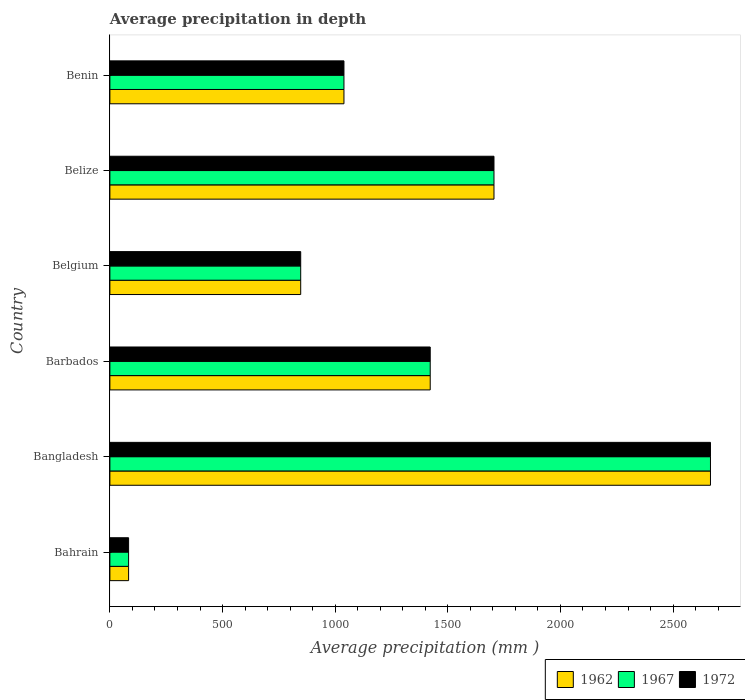How many bars are there on the 6th tick from the bottom?
Give a very brief answer. 3. What is the label of the 1st group of bars from the top?
Give a very brief answer. Benin. What is the average precipitation in 1967 in Belize?
Provide a short and direct response. 1705. Across all countries, what is the maximum average precipitation in 1967?
Offer a very short reply. 2666. Across all countries, what is the minimum average precipitation in 1967?
Your answer should be compact. 83. In which country was the average precipitation in 1962 maximum?
Your answer should be very brief. Bangladesh. In which country was the average precipitation in 1962 minimum?
Your answer should be compact. Bahrain. What is the total average precipitation in 1967 in the graph?
Make the answer very short. 7762. What is the difference between the average precipitation in 1962 in Belize and that in Benin?
Provide a short and direct response. 666. What is the difference between the average precipitation in 1967 in Bangladesh and the average precipitation in 1972 in Bahrain?
Your response must be concise. 2583. What is the average average precipitation in 1972 per country?
Provide a succinct answer. 1293.67. In how many countries, is the average precipitation in 1962 greater than 1300 mm?
Ensure brevity in your answer.  3. What is the ratio of the average precipitation in 1972 in Bahrain to that in Barbados?
Give a very brief answer. 0.06. What is the difference between the highest and the second highest average precipitation in 1967?
Offer a very short reply. 961. What is the difference between the highest and the lowest average precipitation in 1967?
Give a very brief answer. 2583. In how many countries, is the average precipitation in 1962 greater than the average average precipitation in 1962 taken over all countries?
Your answer should be very brief. 3. Is the sum of the average precipitation in 1967 in Barbados and Belize greater than the maximum average precipitation in 1962 across all countries?
Provide a short and direct response. Yes. What does the 1st bar from the top in Bahrain represents?
Provide a short and direct response. 1972. How many bars are there?
Offer a very short reply. 18. How many countries are there in the graph?
Keep it short and to the point. 6. Does the graph contain any zero values?
Ensure brevity in your answer.  No. Does the graph contain grids?
Make the answer very short. No. Where does the legend appear in the graph?
Your answer should be compact. Bottom right. How many legend labels are there?
Provide a short and direct response. 3. What is the title of the graph?
Keep it short and to the point. Average precipitation in depth. Does "1981" appear as one of the legend labels in the graph?
Ensure brevity in your answer.  No. What is the label or title of the X-axis?
Your answer should be very brief. Average precipitation (mm ). What is the label or title of the Y-axis?
Offer a terse response. Country. What is the Average precipitation (mm ) in 1972 in Bahrain?
Your response must be concise. 83. What is the Average precipitation (mm ) in 1962 in Bangladesh?
Offer a very short reply. 2666. What is the Average precipitation (mm ) of 1967 in Bangladesh?
Your response must be concise. 2666. What is the Average precipitation (mm ) of 1972 in Bangladesh?
Your answer should be very brief. 2666. What is the Average precipitation (mm ) in 1962 in Barbados?
Ensure brevity in your answer.  1422. What is the Average precipitation (mm ) of 1967 in Barbados?
Your answer should be very brief. 1422. What is the Average precipitation (mm ) in 1972 in Barbados?
Ensure brevity in your answer.  1422. What is the Average precipitation (mm ) in 1962 in Belgium?
Make the answer very short. 847. What is the Average precipitation (mm ) in 1967 in Belgium?
Offer a terse response. 847. What is the Average precipitation (mm ) in 1972 in Belgium?
Give a very brief answer. 847. What is the Average precipitation (mm ) in 1962 in Belize?
Offer a terse response. 1705. What is the Average precipitation (mm ) in 1967 in Belize?
Your answer should be very brief. 1705. What is the Average precipitation (mm ) in 1972 in Belize?
Offer a very short reply. 1705. What is the Average precipitation (mm ) of 1962 in Benin?
Your answer should be compact. 1039. What is the Average precipitation (mm ) of 1967 in Benin?
Make the answer very short. 1039. What is the Average precipitation (mm ) in 1972 in Benin?
Offer a very short reply. 1039. Across all countries, what is the maximum Average precipitation (mm ) of 1962?
Keep it short and to the point. 2666. Across all countries, what is the maximum Average precipitation (mm ) in 1967?
Provide a succinct answer. 2666. Across all countries, what is the maximum Average precipitation (mm ) in 1972?
Keep it short and to the point. 2666. Across all countries, what is the minimum Average precipitation (mm ) in 1967?
Ensure brevity in your answer.  83. Across all countries, what is the minimum Average precipitation (mm ) in 1972?
Give a very brief answer. 83. What is the total Average precipitation (mm ) in 1962 in the graph?
Provide a short and direct response. 7762. What is the total Average precipitation (mm ) of 1967 in the graph?
Give a very brief answer. 7762. What is the total Average precipitation (mm ) in 1972 in the graph?
Give a very brief answer. 7762. What is the difference between the Average precipitation (mm ) of 1962 in Bahrain and that in Bangladesh?
Your answer should be compact. -2583. What is the difference between the Average precipitation (mm ) in 1967 in Bahrain and that in Bangladesh?
Keep it short and to the point. -2583. What is the difference between the Average precipitation (mm ) in 1972 in Bahrain and that in Bangladesh?
Ensure brevity in your answer.  -2583. What is the difference between the Average precipitation (mm ) of 1962 in Bahrain and that in Barbados?
Offer a very short reply. -1339. What is the difference between the Average precipitation (mm ) of 1967 in Bahrain and that in Barbados?
Make the answer very short. -1339. What is the difference between the Average precipitation (mm ) of 1972 in Bahrain and that in Barbados?
Make the answer very short. -1339. What is the difference between the Average precipitation (mm ) of 1962 in Bahrain and that in Belgium?
Give a very brief answer. -764. What is the difference between the Average precipitation (mm ) of 1967 in Bahrain and that in Belgium?
Offer a very short reply. -764. What is the difference between the Average precipitation (mm ) in 1972 in Bahrain and that in Belgium?
Your response must be concise. -764. What is the difference between the Average precipitation (mm ) in 1962 in Bahrain and that in Belize?
Provide a short and direct response. -1622. What is the difference between the Average precipitation (mm ) in 1967 in Bahrain and that in Belize?
Provide a short and direct response. -1622. What is the difference between the Average precipitation (mm ) of 1972 in Bahrain and that in Belize?
Provide a succinct answer. -1622. What is the difference between the Average precipitation (mm ) of 1962 in Bahrain and that in Benin?
Give a very brief answer. -956. What is the difference between the Average precipitation (mm ) in 1967 in Bahrain and that in Benin?
Give a very brief answer. -956. What is the difference between the Average precipitation (mm ) in 1972 in Bahrain and that in Benin?
Provide a short and direct response. -956. What is the difference between the Average precipitation (mm ) of 1962 in Bangladesh and that in Barbados?
Give a very brief answer. 1244. What is the difference between the Average precipitation (mm ) in 1967 in Bangladesh and that in Barbados?
Offer a very short reply. 1244. What is the difference between the Average precipitation (mm ) in 1972 in Bangladesh and that in Barbados?
Your answer should be very brief. 1244. What is the difference between the Average precipitation (mm ) in 1962 in Bangladesh and that in Belgium?
Ensure brevity in your answer.  1819. What is the difference between the Average precipitation (mm ) of 1967 in Bangladesh and that in Belgium?
Your response must be concise. 1819. What is the difference between the Average precipitation (mm ) in 1972 in Bangladesh and that in Belgium?
Offer a terse response. 1819. What is the difference between the Average precipitation (mm ) in 1962 in Bangladesh and that in Belize?
Provide a short and direct response. 961. What is the difference between the Average precipitation (mm ) of 1967 in Bangladesh and that in Belize?
Your response must be concise. 961. What is the difference between the Average precipitation (mm ) of 1972 in Bangladesh and that in Belize?
Offer a terse response. 961. What is the difference between the Average precipitation (mm ) in 1962 in Bangladesh and that in Benin?
Your answer should be compact. 1627. What is the difference between the Average precipitation (mm ) of 1967 in Bangladesh and that in Benin?
Ensure brevity in your answer.  1627. What is the difference between the Average precipitation (mm ) in 1972 in Bangladesh and that in Benin?
Provide a short and direct response. 1627. What is the difference between the Average precipitation (mm ) of 1962 in Barbados and that in Belgium?
Keep it short and to the point. 575. What is the difference between the Average precipitation (mm ) of 1967 in Barbados and that in Belgium?
Make the answer very short. 575. What is the difference between the Average precipitation (mm ) of 1972 in Barbados and that in Belgium?
Keep it short and to the point. 575. What is the difference between the Average precipitation (mm ) in 1962 in Barbados and that in Belize?
Give a very brief answer. -283. What is the difference between the Average precipitation (mm ) in 1967 in Barbados and that in Belize?
Give a very brief answer. -283. What is the difference between the Average precipitation (mm ) in 1972 in Barbados and that in Belize?
Provide a short and direct response. -283. What is the difference between the Average precipitation (mm ) of 1962 in Barbados and that in Benin?
Provide a succinct answer. 383. What is the difference between the Average precipitation (mm ) in 1967 in Barbados and that in Benin?
Offer a terse response. 383. What is the difference between the Average precipitation (mm ) of 1972 in Barbados and that in Benin?
Make the answer very short. 383. What is the difference between the Average precipitation (mm ) in 1962 in Belgium and that in Belize?
Provide a short and direct response. -858. What is the difference between the Average precipitation (mm ) in 1967 in Belgium and that in Belize?
Offer a terse response. -858. What is the difference between the Average precipitation (mm ) of 1972 in Belgium and that in Belize?
Provide a succinct answer. -858. What is the difference between the Average precipitation (mm ) of 1962 in Belgium and that in Benin?
Offer a very short reply. -192. What is the difference between the Average precipitation (mm ) of 1967 in Belgium and that in Benin?
Provide a short and direct response. -192. What is the difference between the Average precipitation (mm ) of 1972 in Belgium and that in Benin?
Your response must be concise. -192. What is the difference between the Average precipitation (mm ) of 1962 in Belize and that in Benin?
Make the answer very short. 666. What is the difference between the Average precipitation (mm ) in 1967 in Belize and that in Benin?
Make the answer very short. 666. What is the difference between the Average precipitation (mm ) in 1972 in Belize and that in Benin?
Your response must be concise. 666. What is the difference between the Average precipitation (mm ) in 1962 in Bahrain and the Average precipitation (mm ) in 1967 in Bangladesh?
Your answer should be compact. -2583. What is the difference between the Average precipitation (mm ) of 1962 in Bahrain and the Average precipitation (mm ) of 1972 in Bangladesh?
Your response must be concise. -2583. What is the difference between the Average precipitation (mm ) of 1967 in Bahrain and the Average precipitation (mm ) of 1972 in Bangladesh?
Offer a terse response. -2583. What is the difference between the Average precipitation (mm ) of 1962 in Bahrain and the Average precipitation (mm ) of 1967 in Barbados?
Offer a terse response. -1339. What is the difference between the Average precipitation (mm ) of 1962 in Bahrain and the Average precipitation (mm ) of 1972 in Barbados?
Your response must be concise. -1339. What is the difference between the Average precipitation (mm ) in 1967 in Bahrain and the Average precipitation (mm ) in 1972 in Barbados?
Your response must be concise. -1339. What is the difference between the Average precipitation (mm ) in 1962 in Bahrain and the Average precipitation (mm ) in 1967 in Belgium?
Provide a succinct answer. -764. What is the difference between the Average precipitation (mm ) in 1962 in Bahrain and the Average precipitation (mm ) in 1972 in Belgium?
Ensure brevity in your answer.  -764. What is the difference between the Average precipitation (mm ) of 1967 in Bahrain and the Average precipitation (mm ) of 1972 in Belgium?
Give a very brief answer. -764. What is the difference between the Average precipitation (mm ) of 1962 in Bahrain and the Average precipitation (mm ) of 1967 in Belize?
Give a very brief answer. -1622. What is the difference between the Average precipitation (mm ) of 1962 in Bahrain and the Average precipitation (mm ) of 1972 in Belize?
Offer a very short reply. -1622. What is the difference between the Average precipitation (mm ) of 1967 in Bahrain and the Average precipitation (mm ) of 1972 in Belize?
Ensure brevity in your answer.  -1622. What is the difference between the Average precipitation (mm ) of 1962 in Bahrain and the Average precipitation (mm ) of 1967 in Benin?
Your response must be concise. -956. What is the difference between the Average precipitation (mm ) in 1962 in Bahrain and the Average precipitation (mm ) in 1972 in Benin?
Give a very brief answer. -956. What is the difference between the Average precipitation (mm ) in 1967 in Bahrain and the Average precipitation (mm ) in 1972 in Benin?
Your answer should be compact. -956. What is the difference between the Average precipitation (mm ) of 1962 in Bangladesh and the Average precipitation (mm ) of 1967 in Barbados?
Provide a succinct answer. 1244. What is the difference between the Average precipitation (mm ) in 1962 in Bangladesh and the Average precipitation (mm ) in 1972 in Barbados?
Your answer should be very brief. 1244. What is the difference between the Average precipitation (mm ) of 1967 in Bangladesh and the Average precipitation (mm ) of 1972 in Barbados?
Make the answer very short. 1244. What is the difference between the Average precipitation (mm ) in 1962 in Bangladesh and the Average precipitation (mm ) in 1967 in Belgium?
Your answer should be compact. 1819. What is the difference between the Average precipitation (mm ) in 1962 in Bangladesh and the Average precipitation (mm ) in 1972 in Belgium?
Make the answer very short. 1819. What is the difference between the Average precipitation (mm ) in 1967 in Bangladesh and the Average precipitation (mm ) in 1972 in Belgium?
Keep it short and to the point. 1819. What is the difference between the Average precipitation (mm ) in 1962 in Bangladesh and the Average precipitation (mm ) in 1967 in Belize?
Make the answer very short. 961. What is the difference between the Average precipitation (mm ) of 1962 in Bangladesh and the Average precipitation (mm ) of 1972 in Belize?
Give a very brief answer. 961. What is the difference between the Average precipitation (mm ) of 1967 in Bangladesh and the Average precipitation (mm ) of 1972 in Belize?
Your answer should be very brief. 961. What is the difference between the Average precipitation (mm ) in 1962 in Bangladesh and the Average precipitation (mm ) in 1967 in Benin?
Keep it short and to the point. 1627. What is the difference between the Average precipitation (mm ) in 1962 in Bangladesh and the Average precipitation (mm ) in 1972 in Benin?
Make the answer very short. 1627. What is the difference between the Average precipitation (mm ) in 1967 in Bangladesh and the Average precipitation (mm ) in 1972 in Benin?
Ensure brevity in your answer.  1627. What is the difference between the Average precipitation (mm ) of 1962 in Barbados and the Average precipitation (mm ) of 1967 in Belgium?
Provide a short and direct response. 575. What is the difference between the Average precipitation (mm ) of 1962 in Barbados and the Average precipitation (mm ) of 1972 in Belgium?
Your answer should be very brief. 575. What is the difference between the Average precipitation (mm ) in 1967 in Barbados and the Average precipitation (mm ) in 1972 in Belgium?
Make the answer very short. 575. What is the difference between the Average precipitation (mm ) of 1962 in Barbados and the Average precipitation (mm ) of 1967 in Belize?
Give a very brief answer. -283. What is the difference between the Average precipitation (mm ) of 1962 in Barbados and the Average precipitation (mm ) of 1972 in Belize?
Your response must be concise. -283. What is the difference between the Average precipitation (mm ) of 1967 in Barbados and the Average precipitation (mm ) of 1972 in Belize?
Give a very brief answer. -283. What is the difference between the Average precipitation (mm ) in 1962 in Barbados and the Average precipitation (mm ) in 1967 in Benin?
Ensure brevity in your answer.  383. What is the difference between the Average precipitation (mm ) of 1962 in Barbados and the Average precipitation (mm ) of 1972 in Benin?
Your answer should be compact. 383. What is the difference between the Average precipitation (mm ) of 1967 in Barbados and the Average precipitation (mm ) of 1972 in Benin?
Give a very brief answer. 383. What is the difference between the Average precipitation (mm ) of 1962 in Belgium and the Average precipitation (mm ) of 1967 in Belize?
Offer a terse response. -858. What is the difference between the Average precipitation (mm ) of 1962 in Belgium and the Average precipitation (mm ) of 1972 in Belize?
Provide a succinct answer. -858. What is the difference between the Average precipitation (mm ) of 1967 in Belgium and the Average precipitation (mm ) of 1972 in Belize?
Make the answer very short. -858. What is the difference between the Average precipitation (mm ) of 1962 in Belgium and the Average precipitation (mm ) of 1967 in Benin?
Provide a succinct answer. -192. What is the difference between the Average precipitation (mm ) in 1962 in Belgium and the Average precipitation (mm ) in 1972 in Benin?
Your answer should be very brief. -192. What is the difference between the Average precipitation (mm ) in 1967 in Belgium and the Average precipitation (mm ) in 1972 in Benin?
Provide a short and direct response. -192. What is the difference between the Average precipitation (mm ) of 1962 in Belize and the Average precipitation (mm ) of 1967 in Benin?
Provide a short and direct response. 666. What is the difference between the Average precipitation (mm ) of 1962 in Belize and the Average precipitation (mm ) of 1972 in Benin?
Keep it short and to the point. 666. What is the difference between the Average precipitation (mm ) of 1967 in Belize and the Average precipitation (mm ) of 1972 in Benin?
Provide a succinct answer. 666. What is the average Average precipitation (mm ) in 1962 per country?
Your answer should be very brief. 1293.67. What is the average Average precipitation (mm ) in 1967 per country?
Your answer should be compact. 1293.67. What is the average Average precipitation (mm ) of 1972 per country?
Keep it short and to the point. 1293.67. What is the difference between the Average precipitation (mm ) in 1962 and Average precipitation (mm ) in 1972 in Bahrain?
Make the answer very short. 0. What is the difference between the Average precipitation (mm ) in 1967 and Average precipitation (mm ) in 1972 in Bahrain?
Offer a very short reply. 0. What is the difference between the Average precipitation (mm ) in 1962 and Average precipitation (mm ) in 1967 in Bangladesh?
Your answer should be very brief. 0. What is the difference between the Average precipitation (mm ) of 1967 and Average precipitation (mm ) of 1972 in Bangladesh?
Your answer should be compact. 0. What is the difference between the Average precipitation (mm ) in 1962 and Average precipitation (mm ) in 1967 in Barbados?
Offer a terse response. 0. What is the difference between the Average precipitation (mm ) of 1967 and Average precipitation (mm ) of 1972 in Barbados?
Your answer should be compact. 0. What is the difference between the Average precipitation (mm ) in 1962 and Average precipitation (mm ) in 1972 in Belgium?
Your answer should be very brief. 0. What is the difference between the Average precipitation (mm ) of 1962 and Average precipitation (mm ) of 1967 in Belize?
Offer a terse response. 0. What is the difference between the Average precipitation (mm ) of 1967 and Average precipitation (mm ) of 1972 in Belize?
Provide a short and direct response. 0. What is the difference between the Average precipitation (mm ) in 1962 and Average precipitation (mm ) in 1967 in Benin?
Your answer should be compact. 0. What is the difference between the Average precipitation (mm ) of 1962 and Average precipitation (mm ) of 1972 in Benin?
Make the answer very short. 0. What is the ratio of the Average precipitation (mm ) in 1962 in Bahrain to that in Bangladesh?
Offer a very short reply. 0.03. What is the ratio of the Average precipitation (mm ) in 1967 in Bahrain to that in Bangladesh?
Make the answer very short. 0.03. What is the ratio of the Average precipitation (mm ) in 1972 in Bahrain to that in Bangladesh?
Provide a short and direct response. 0.03. What is the ratio of the Average precipitation (mm ) in 1962 in Bahrain to that in Barbados?
Offer a terse response. 0.06. What is the ratio of the Average precipitation (mm ) of 1967 in Bahrain to that in Barbados?
Keep it short and to the point. 0.06. What is the ratio of the Average precipitation (mm ) of 1972 in Bahrain to that in Barbados?
Your answer should be compact. 0.06. What is the ratio of the Average precipitation (mm ) of 1962 in Bahrain to that in Belgium?
Your answer should be very brief. 0.1. What is the ratio of the Average precipitation (mm ) of 1967 in Bahrain to that in Belgium?
Offer a terse response. 0.1. What is the ratio of the Average precipitation (mm ) of 1972 in Bahrain to that in Belgium?
Your response must be concise. 0.1. What is the ratio of the Average precipitation (mm ) in 1962 in Bahrain to that in Belize?
Keep it short and to the point. 0.05. What is the ratio of the Average precipitation (mm ) of 1967 in Bahrain to that in Belize?
Your response must be concise. 0.05. What is the ratio of the Average precipitation (mm ) in 1972 in Bahrain to that in Belize?
Give a very brief answer. 0.05. What is the ratio of the Average precipitation (mm ) of 1962 in Bahrain to that in Benin?
Ensure brevity in your answer.  0.08. What is the ratio of the Average precipitation (mm ) in 1967 in Bahrain to that in Benin?
Give a very brief answer. 0.08. What is the ratio of the Average precipitation (mm ) in 1972 in Bahrain to that in Benin?
Your response must be concise. 0.08. What is the ratio of the Average precipitation (mm ) of 1962 in Bangladesh to that in Barbados?
Offer a very short reply. 1.87. What is the ratio of the Average precipitation (mm ) in 1967 in Bangladesh to that in Barbados?
Your answer should be compact. 1.87. What is the ratio of the Average precipitation (mm ) of 1972 in Bangladesh to that in Barbados?
Offer a very short reply. 1.87. What is the ratio of the Average precipitation (mm ) of 1962 in Bangladesh to that in Belgium?
Provide a short and direct response. 3.15. What is the ratio of the Average precipitation (mm ) of 1967 in Bangladesh to that in Belgium?
Ensure brevity in your answer.  3.15. What is the ratio of the Average precipitation (mm ) of 1972 in Bangladesh to that in Belgium?
Offer a very short reply. 3.15. What is the ratio of the Average precipitation (mm ) of 1962 in Bangladesh to that in Belize?
Give a very brief answer. 1.56. What is the ratio of the Average precipitation (mm ) of 1967 in Bangladesh to that in Belize?
Offer a terse response. 1.56. What is the ratio of the Average precipitation (mm ) in 1972 in Bangladesh to that in Belize?
Give a very brief answer. 1.56. What is the ratio of the Average precipitation (mm ) in 1962 in Bangladesh to that in Benin?
Ensure brevity in your answer.  2.57. What is the ratio of the Average precipitation (mm ) in 1967 in Bangladesh to that in Benin?
Make the answer very short. 2.57. What is the ratio of the Average precipitation (mm ) in 1972 in Bangladesh to that in Benin?
Ensure brevity in your answer.  2.57. What is the ratio of the Average precipitation (mm ) of 1962 in Barbados to that in Belgium?
Offer a terse response. 1.68. What is the ratio of the Average precipitation (mm ) of 1967 in Barbados to that in Belgium?
Your response must be concise. 1.68. What is the ratio of the Average precipitation (mm ) of 1972 in Barbados to that in Belgium?
Make the answer very short. 1.68. What is the ratio of the Average precipitation (mm ) of 1962 in Barbados to that in Belize?
Keep it short and to the point. 0.83. What is the ratio of the Average precipitation (mm ) in 1967 in Barbados to that in Belize?
Make the answer very short. 0.83. What is the ratio of the Average precipitation (mm ) of 1972 in Barbados to that in Belize?
Provide a succinct answer. 0.83. What is the ratio of the Average precipitation (mm ) of 1962 in Barbados to that in Benin?
Provide a succinct answer. 1.37. What is the ratio of the Average precipitation (mm ) of 1967 in Barbados to that in Benin?
Your answer should be compact. 1.37. What is the ratio of the Average precipitation (mm ) in 1972 in Barbados to that in Benin?
Your answer should be very brief. 1.37. What is the ratio of the Average precipitation (mm ) in 1962 in Belgium to that in Belize?
Your response must be concise. 0.5. What is the ratio of the Average precipitation (mm ) of 1967 in Belgium to that in Belize?
Your response must be concise. 0.5. What is the ratio of the Average precipitation (mm ) in 1972 in Belgium to that in Belize?
Provide a short and direct response. 0.5. What is the ratio of the Average precipitation (mm ) in 1962 in Belgium to that in Benin?
Give a very brief answer. 0.82. What is the ratio of the Average precipitation (mm ) in 1967 in Belgium to that in Benin?
Your response must be concise. 0.82. What is the ratio of the Average precipitation (mm ) of 1972 in Belgium to that in Benin?
Give a very brief answer. 0.82. What is the ratio of the Average precipitation (mm ) in 1962 in Belize to that in Benin?
Make the answer very short. 1.64. What is the ratio of the Average precipitation (mm ) of 1967 in Belize to that in Benin?
Ensure brevity in your answer.  1.64. What is the ratio of the Average precipitation (mm ) of 1972 in Belize to that in Benin?
Make the answer very short. 1.64. What is the difference between the highest and the second highest Average precipitation (mm ) of 1962?
Your response must be concise. 961. What is the difference between the highest and the second highest Average precipitation (mm ) of 1967?
Your answer should be compact. 961. What is the difference between the highest and the second highest Average precipitation (mm ) in 1972?
Your response must be concise. 961. What is the difference between the highest and the lowest Average precipitation (mm ) of 1962?
Give a very brief answer. 2583. What is the difference between the highest and the lowest Average precipitation (mm ) of 1967?
Make the answer very short. 2583. What is the difference between the highest and the lowest Average precipitation (mm ) of 1972?
Give a very brief answer. 2583. 